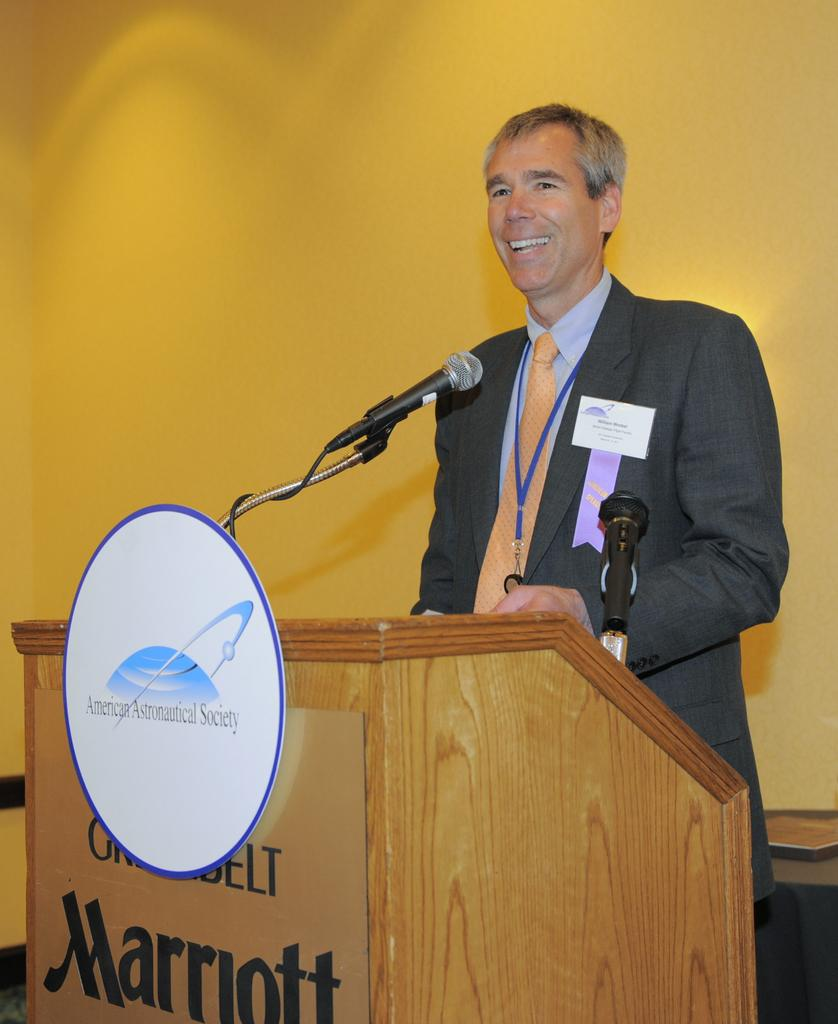Who is the main subject in the image? There is a man in the image. What is the man standing in front of? There is a podium in front of the man. What might the man be using to amplify his voice? There are microphones on or near the podium. What can be seen behind the man? There is a wall visible in the background of the image. What type of donkey can be seen making a discovery in the image? There is no donkey or discovery present in the image. What type of dinner is being served at the event in the image? There is no dinner or event present in the image. 